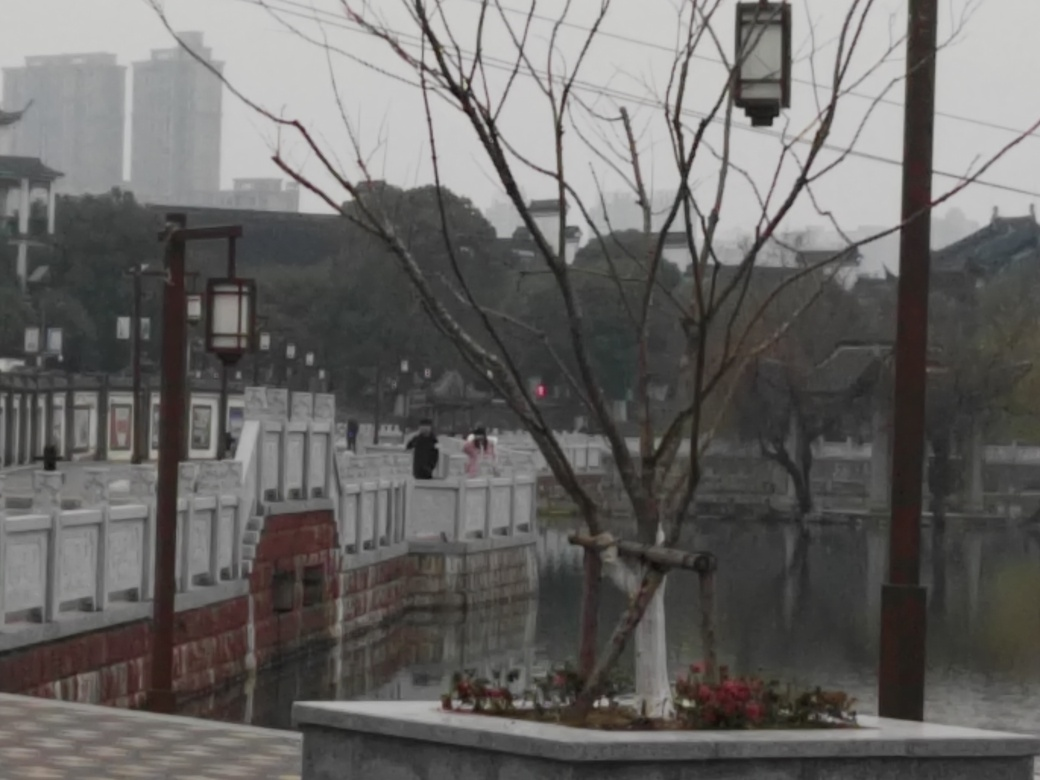Is the lighting sufficient in the image? Based on the image, the lighting appears to be adequate for a gloomy or overcast day, offering a clear view of the scene without harsh shadows or overexposure. The natural diffused light accentuates the tranquil ambiance of the riverside walkway, lending the photograph an authentic portrayal of a misty day. 